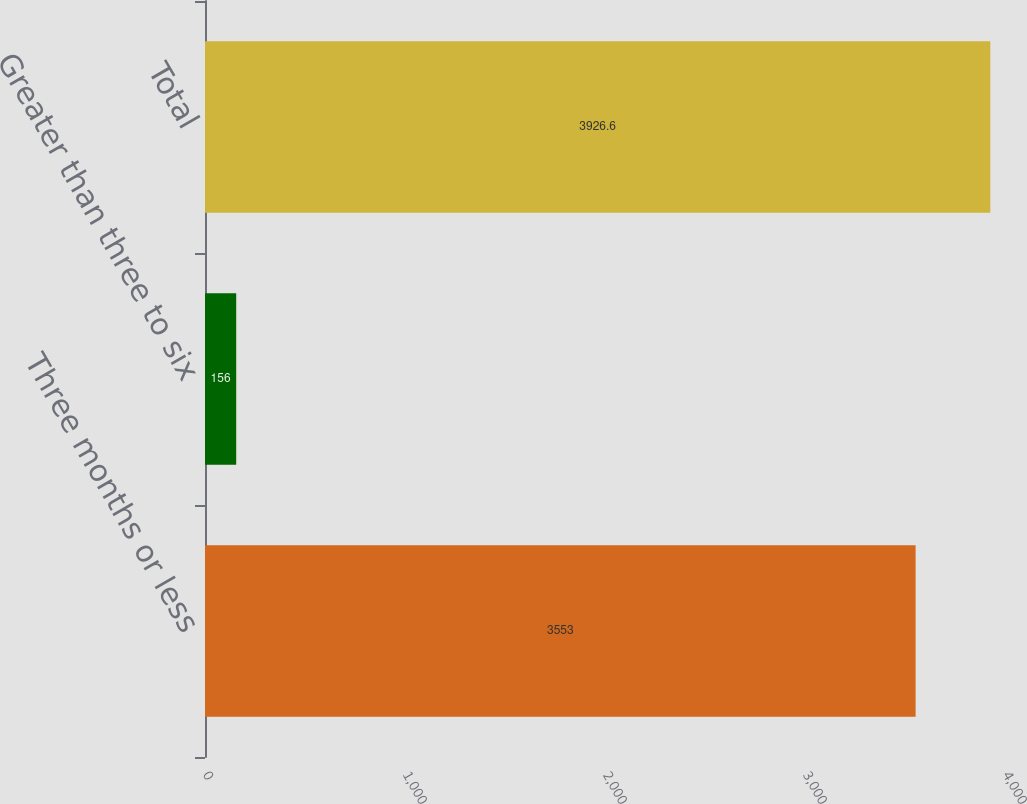Convert chart. <chart><loc_0><loc_0><loc_500><loc_500><bar_chart><fcel>Three months or less<fcel>Greater than three to six<fcel>Total<nl><fcel>3553<fcel>156<fcel>3926.6<nl></chart> 